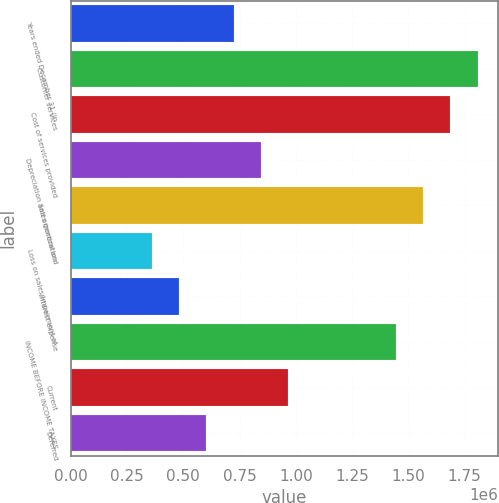Convert chart. <chart><loc_0><loc_0><loc_500><loc_500><bar_chart><fcel>Years ended December 31 (in<fcel>Customer services<fcel>Cost of services provided<fcel>Depreciation and amortization<fcel>Sales general and<fcel>Loss on sales/impairment of<fcel>Interest expense<fcel>INCOME BEFORE INCOME TAXES<fcel>Current<fcel>Deferred<nl><fcel>723038<fcel>1.8076e+06<fcel>1.68709e+06<fcel>843545<fcel>1.56658e+06<fcel>361519<fcel>482026<fcel>1.44608e+06<fcel>964051<fcel>602532<nl></chart> 